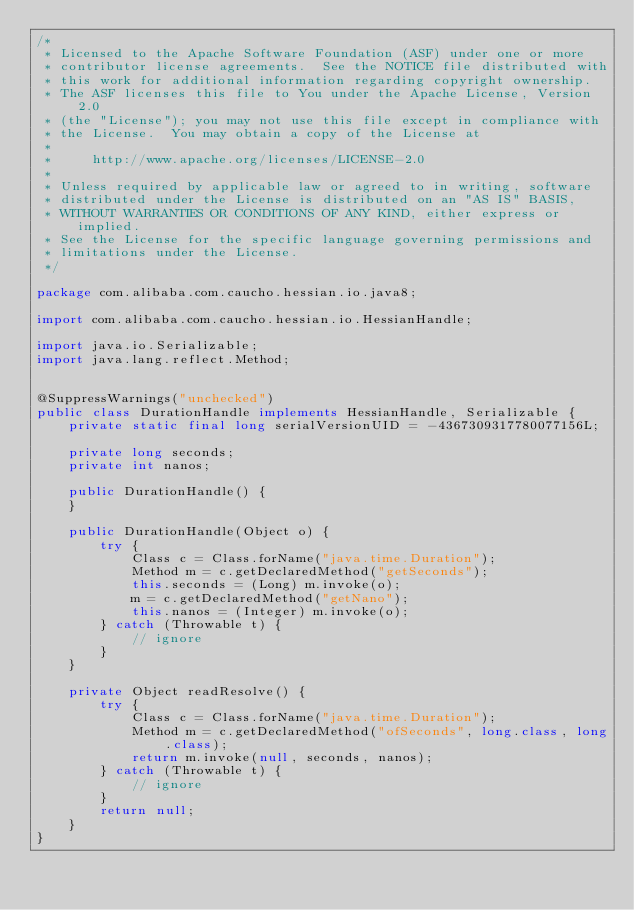Convert code to text. <code><loc_0><loc_0><loc_500><loc_500><_Java_>/*
 * Licensed to the Apache Software Foundation (ASF) under one or more
 * contributor license agreements.  See the NOTICE file distributed with
 * this work for additional information regarding copyright ownership.
 * The ASF licenses this file to You under the Apache License, Version 2.0
 * (the "License"); you may not use this file except in compliance with
 * the License.  You may obtain a copy of the License at
 *
 *     http://www.apache.org/licenses/LICENSE-2.0
 *
 * Unless required by applicable law or agreed to in writing, software
 * distributed under the License is distributed on an "AS IS" BASIS,
 * WITHOUT WARRANTIES OR CONDITIONS OF ANY KIND, either express or implied.
 * See the License for the specific language governing permissions and
 * limitations under the License.
 */

package com.alibaba.com.caucho.hessian.io.java8;

import com.alibaba.com.caucho.hessian.io.HessianHandle;

import java.io.Serializable;
import java.lang.reflect.Method;


@SuppressWarnings("unchecked")
public class DurationHandle implements HessianHandle, Serializable {
    private static final long serialVersionUID = -4367309317780077156L;

    private long seconds;
    private int nanos;

    public DurationHandle() {
    }

    public DurationHandle(Object o) {
        try {
            Class c = Class.forName("java.time.Duration");
            Method m = c.getDeclaredMethod("getSeconds");
            this.seconds = (Long) m.invoke(o);
            m = c.getDeclaredMethod("getNano");
            this.nanos = (Integer) m.invoke(o);
        } catch (Throwable t) {
            // ignore
        }
    }

    private Object readResolve() {
        try {
            Class c = Class.forName("java.time.Duration");
            Method m = c.getDeclaredMethod("ofSeconds", long.class, long.class);
            return m.invoke(null, seconds, nanos);
        } catch (Throwable t) {
            // ignore
        }
        return null;
    }
}
</code> 